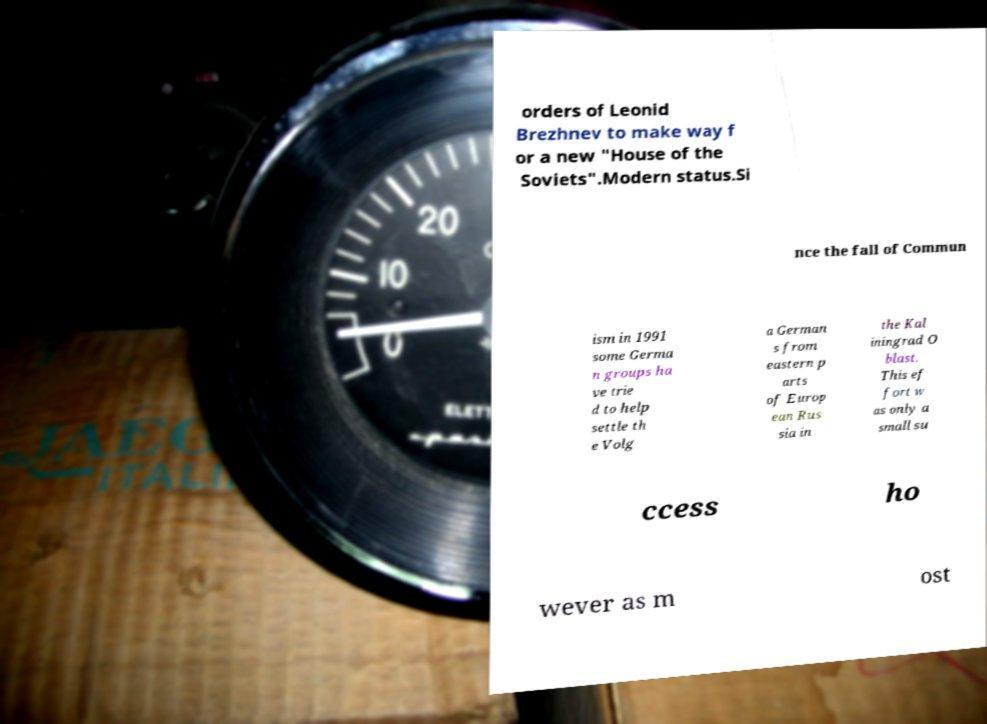Please identify and transcribe the text found in this image. orders of Leonid Brezhnev to make way f or a new "House of the Soviets".Modern status.Si nce the fall of Commun ism in 1991 some Germa n groups ha ve trie d to help settle th e Volg a German s from eastern p arts of Europ ean Rus sia in the Kal iningrad O blast. This ef fort w as only a small su ccess ho wever as m ost 